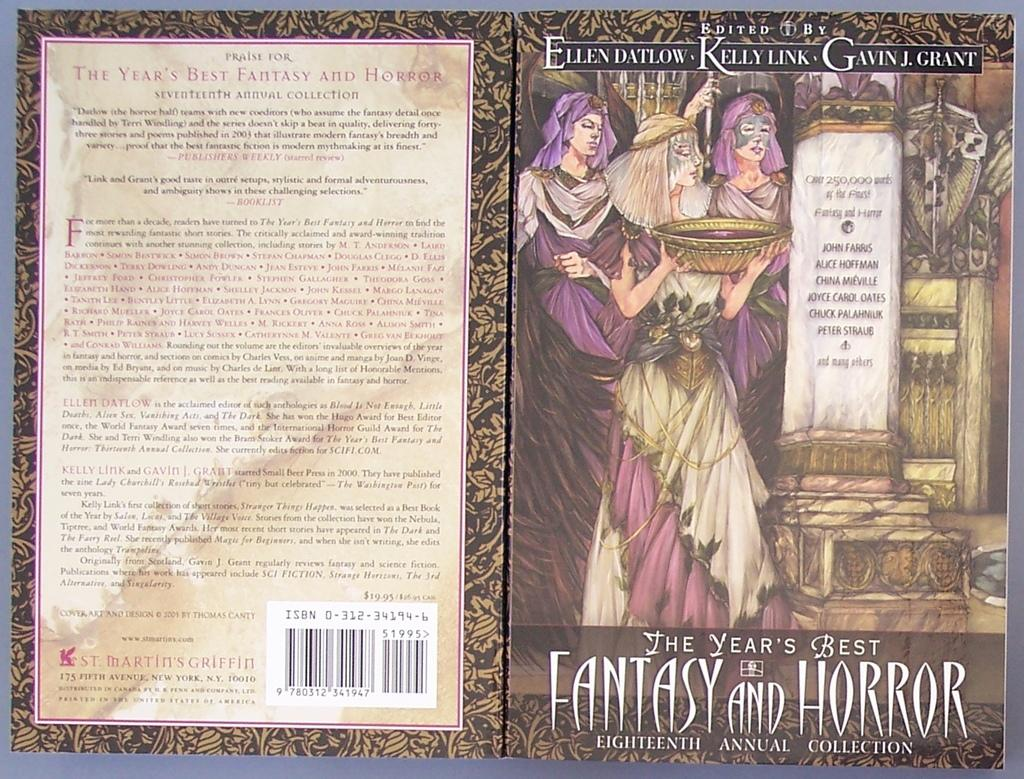<image>
Relay a brief, clear account of the picture shown. a book titled 'the year's best fantasy and horror' 